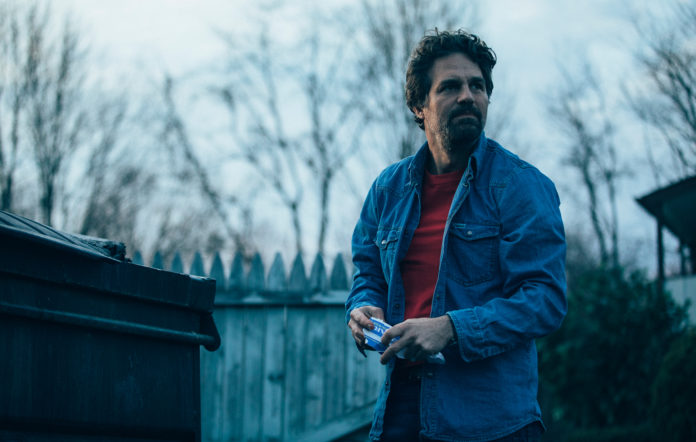Can you describe the main features of this image for me? In this image, there is a man who resembles an actor standing in what appears to be a suburban neighborhood. He is dressed in a casual blue denim jacket over a red shirt and is holding a small object, possibly a phone, in his right hand. His gaze is directed off to the side, suggesting he's focused on something outside the frame. His expression is serious, possibly indicating he is engaged in something important or concerning. The background features a rustic-looking wooden fence, some leafless trees, and the overall atmosphere is serene, although it contrasts with the man's intense expression. 